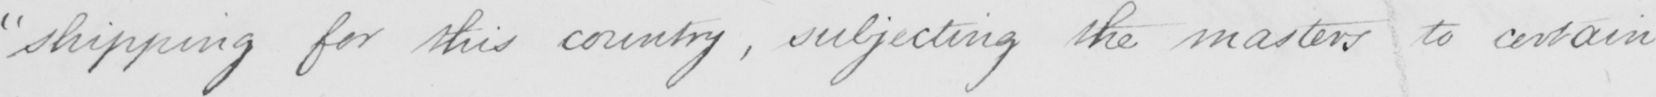What does this handwritten line say? " shipping for this country , subjecting the masters to certain 